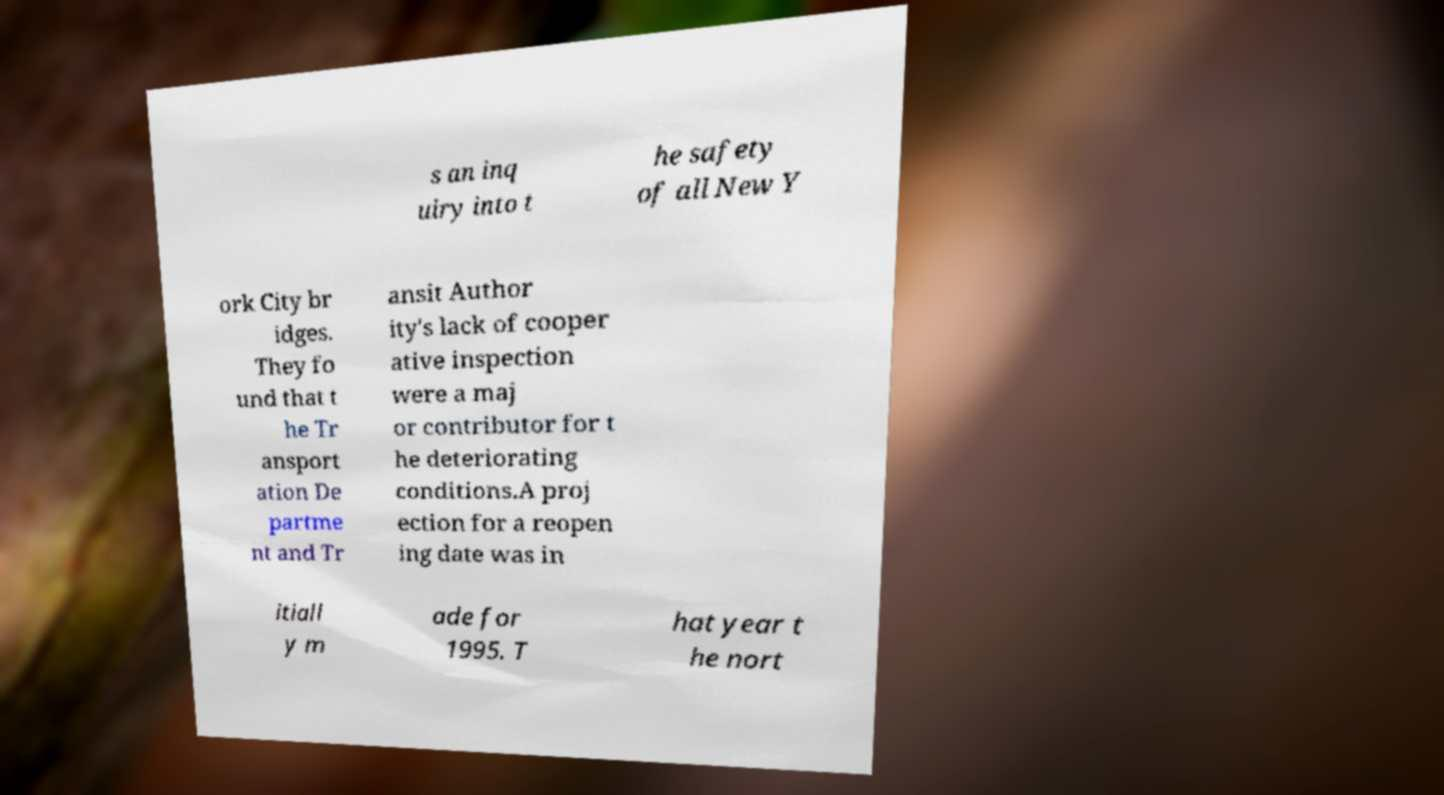For documentation purposes, I need the text within this image transcribed. Could you provide that? s an inq uiry into t he safety of all New Y ork City br idges. They fo und that t he Tr ansport ation De partme nt and Tr ansit Author ity's lack of cooper ative inspection were a maj or contributor for t he deteriorating conditions.A proj ection for a reopen ing date was in itiall y m ade for 1995. T hat year t he nort 